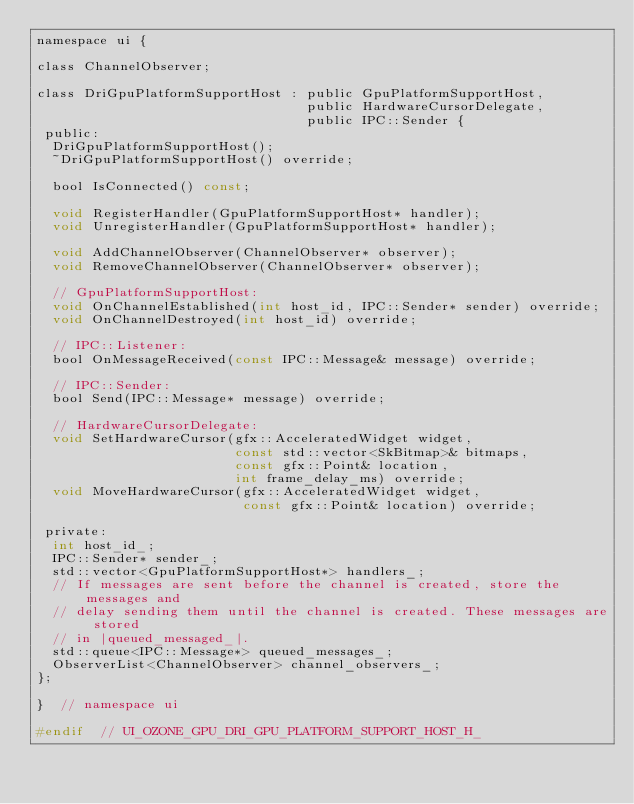<code> <loc_0><loc_0><loc_500><loc_500><_C_>namespace ui {

class ChannelObserver;

class DriGpuPlatformSupportHost : public GpuPlatformSupportHost,
                                  public HardwareCursorDelegate,
                                  public IPC::Sender {
 public:
  DriGpuPlatformSupportHost();
  ~DriGpuPlatformSupportHost() override;

  bool IsConnected() const;

  void RegisterHandler(GpuPlatformSupportHost* handler);
  void UnregisterHandler(GpuPlatformSupportHost* handler);

  void AddChannelObserver(ChannelObserver* observer);
  void RemoveChannelObserver(ChannelObserver* observer);

  // GpuPlatformSupportHost:
  void OnChannelEstablished(int host_id, IPC::Sender* sender) override;
  void OnChannelDestroyed(int host_id) override;

  // IPC::Listener:
  bool OnMessageReceived(const IPC::Message& message) override;

  // IPC::Sender:
  bool Send(IPC::Message* message) override;

  // HardwareCursorDelegate:
  void SetHardwareCursor(gfx::AcceleratedWidget widget,
                         const std::vector<SkBitmap>& bitmaps,
                         const gfx::Point& location,
                         int frame_delay_ms) override;
  void MoveHardwareCursor(gfx::AcceleratedWidget widget,
                          const gfx::Point& location) override;

 private:
  int host_id_;
  IPC::Sender* sender_;
  std::vector<GpuPlatformSupportHost*> handlers_;
  // If messages are sent before the channel is created, store the messages and
  // delay sending them until the channel is created. These messages are stored
  // in |queued_messaged_|.
  std::queue<IPC::Message*> queued_messages_;
  ObserverList<ChannelObserver> channel_observers_;
};

}  // namespace ui

#endif  // UI_OZONE_GPU_DRI_GPU_PLATFORM_SUPPORT_HOST_H_
</code> 